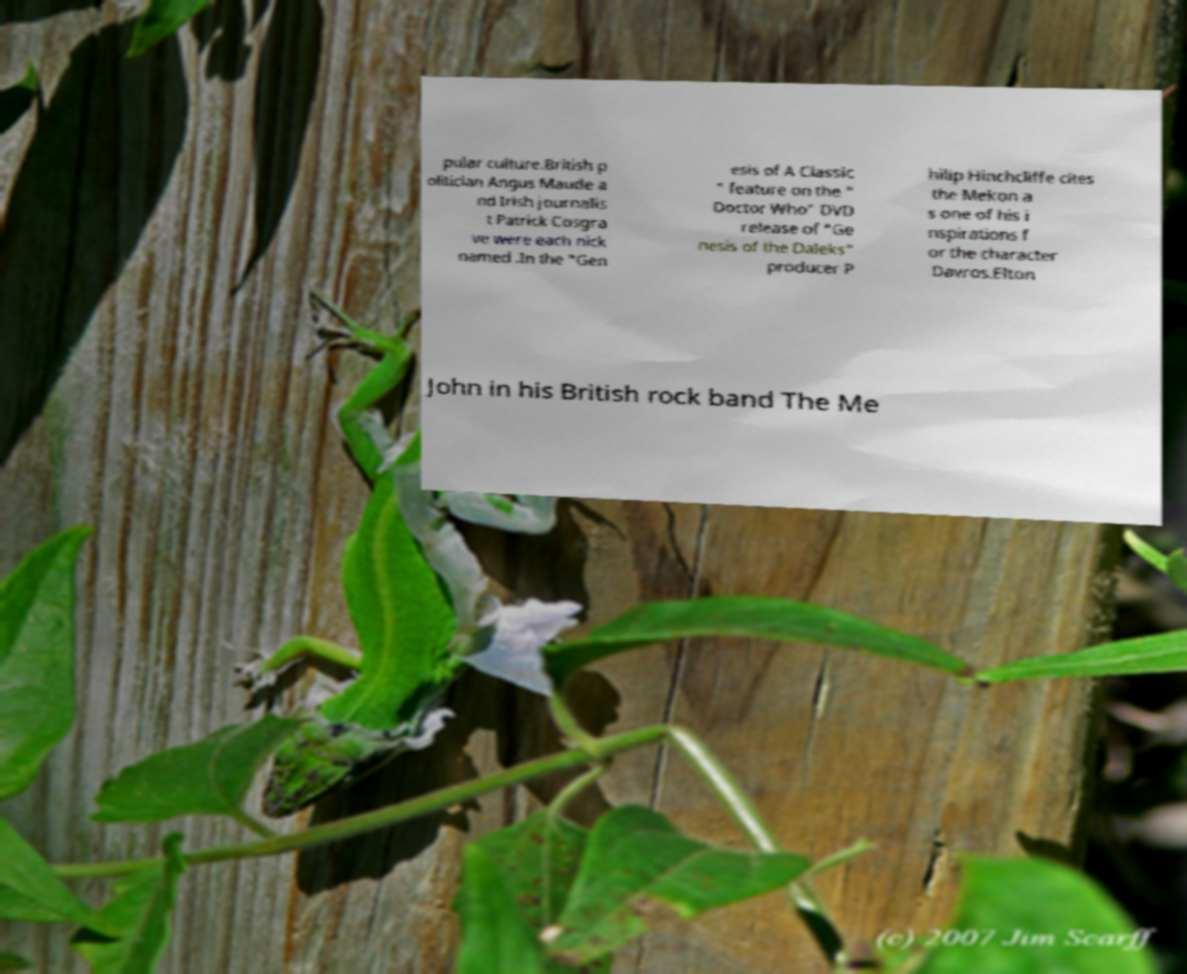What messages or text are displayed in this image? I need them in a readable, typed format. pular culture.British p olitician Angus Maude a nd Irish journalis t Patrick Cosgra ve were each nick named .In the "Gen esis of A Classic " feature on the " Doctor Who" DVD release of "Ge nesis of the Daleks" producer P hilip Hinchcliffe cites the Mekon a s one of his i nspirations f or the character Davros.Elton John in his British rock band The Me 